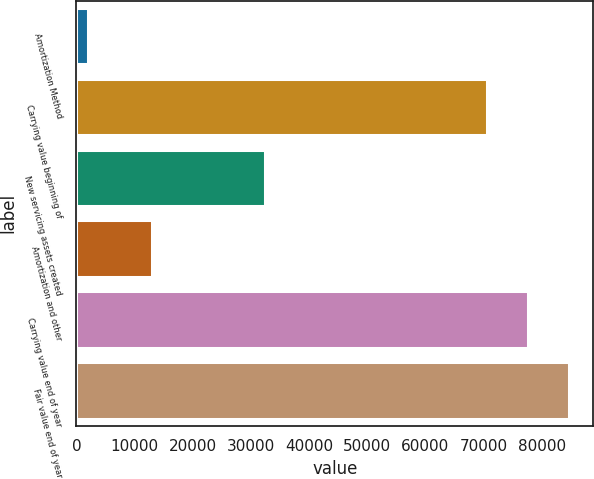Convert chart to OTSL. <chart><loc_0><loc_0><loc_500><loc_500><bar_chart><fcel>Amortization Method<fcel>Carrying value beginning of<fcel>New servicing assets created<fcel>Amortization and other<fcel>Carrying value end of year<fcel>Fair value end of year<nl><fcel>2011<fcel>70516<fcel>32505<fcel>12938<fcel>77573.5<fcel>84631<nl></chart> 